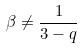<formula> <loc_0><loc_0><loc_500><loc_500>\beta \ne \frac { 1 } { 3 - q }</formula> 